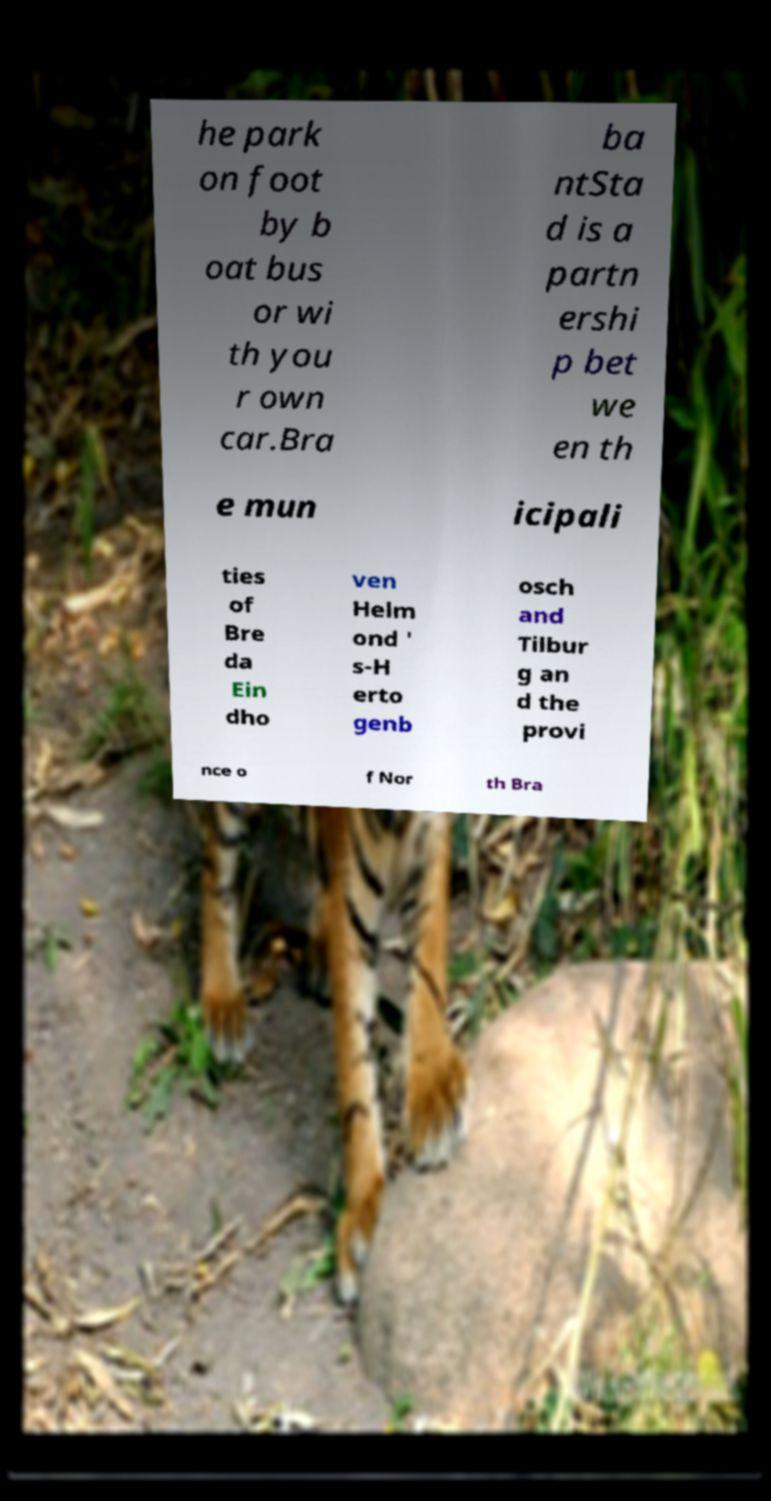Can you read and provide the text displayed in the image?This photo seems to have some interesting text. Can you extract and type it out for me? he park on foot by b oat bus or wi th you r own car.Bra ba ntSta d is a partn ershi p bet we en th e mun icipali ties of Bre da Ein dho ven Helm ond ' s-H erto genb osch and Tilbur g an d the provi nce o f Nor th Bra 